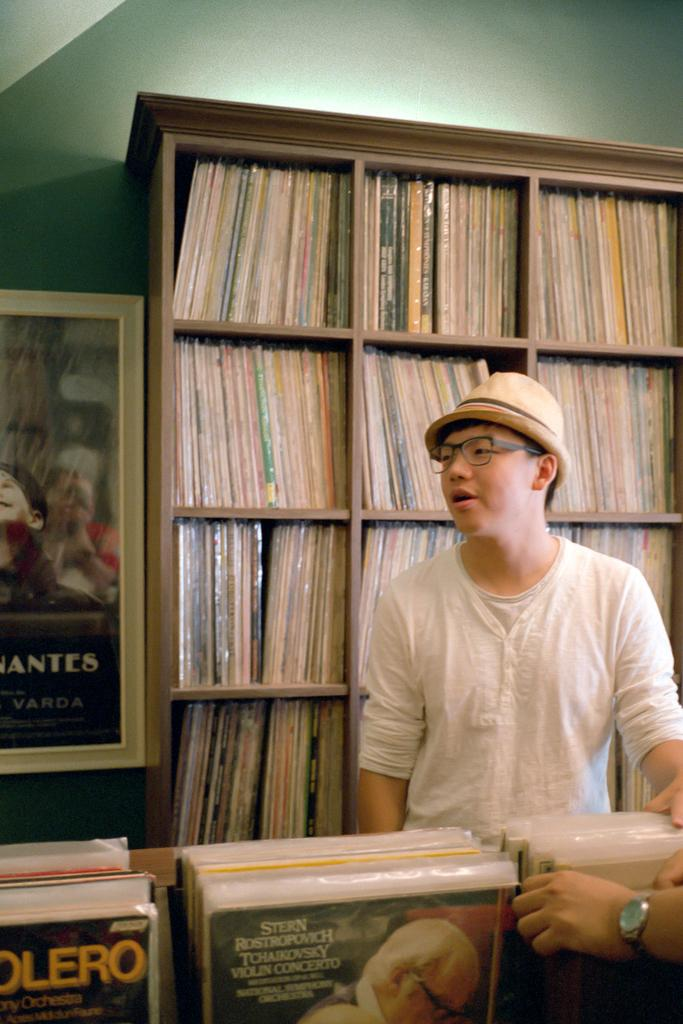Provide a one-sentence caption for the provided image. A man is in a record shop and one of the records is for Tchaikovsky. 